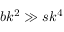<formula> <loc_0><loc_0><loc_500><loc_500>b k ^ { 2 } \gg s k ^ { 4 }</formula> 